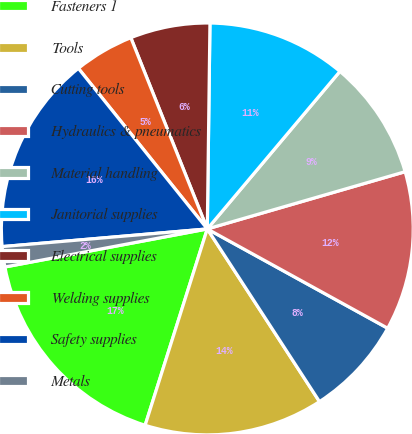<chart> <loc_0><loc_0><loc_500><loc_500><pie_chart><fcel>Fasteners 1<fcel>Tools<fcel>Cutting tools<fcel>Hydraulics & pneumatics<fcel>Material handling<fcel>Janitorial supplies<fcel>Electrical supplies<fcel>Welding supplies<fcel>Safety supplies<fcel>Metals<nl><fcel>17.16%<fcel>14.05%<fcel>7.82%<fcel>12.49%<fcel>9.38%<fcel>10.93%<fcel>6.26%<fcel>4.71%<fcel>15.6%<fcel>1.59%<nl></chart> 